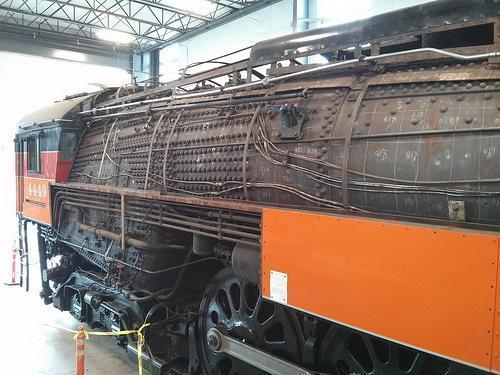How many people are standing near the train?
Give a very brief answer. 0. 